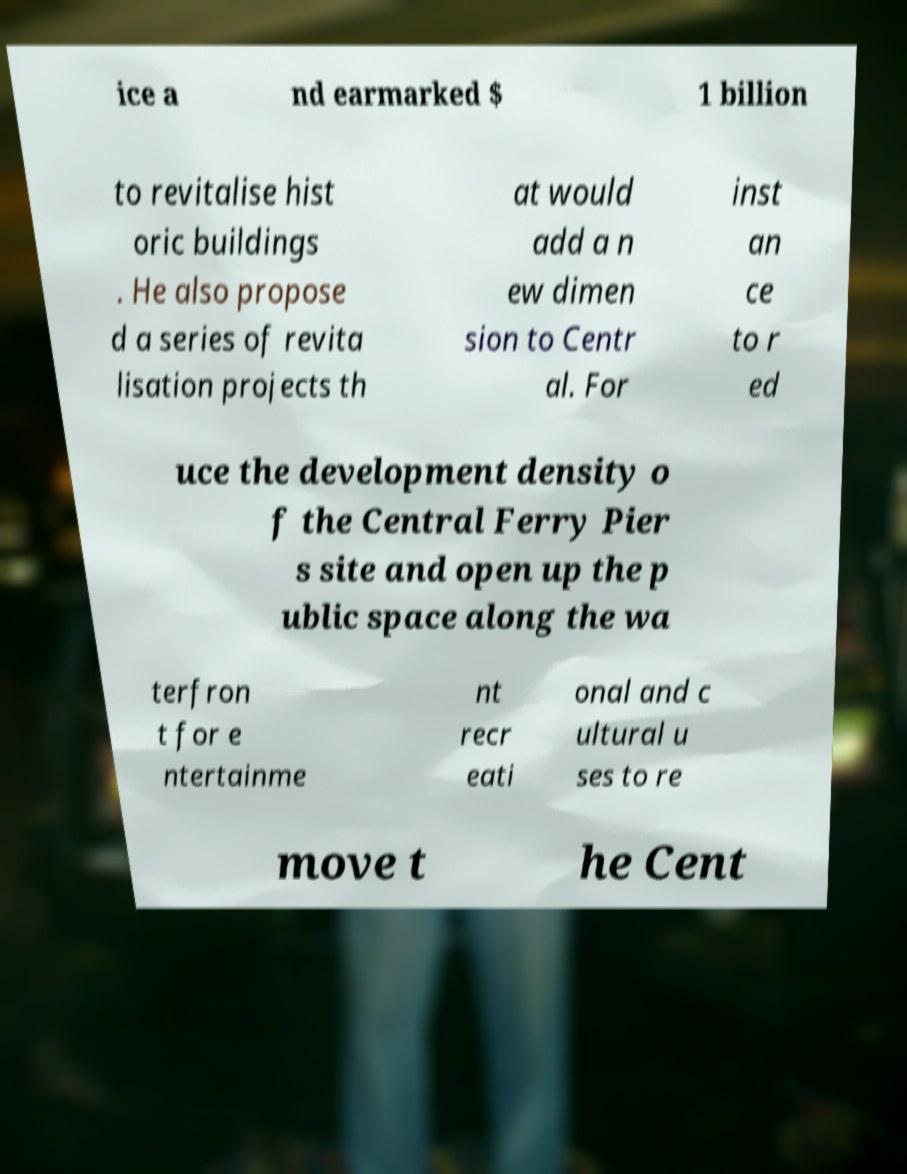Please identify and transcribe the text found in this image. ice a nd earmarked $ 1 billion to revitalise hist oric buildings . He also propose d a series of revita lisation projects th at would add a n ew dimen sion to Centr al. For inst an ce to r ed uce the development density o f the Central Ferry Pier s site and open up the p ublic space along the wa terfron t for e ntertainme nt recr eati onal and c ultural u ses to re move t he Cent 